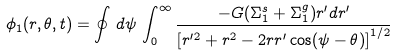Convert formula to latex. <formula><loc_0><loc_0><loc_500><loc_500>\phi _ { 1 } ( r , \theta , t ) = \oint \, d \psi \, \int _ { 0 } ^ { \infty } \frac { - G ( \Sigma _ { 1 } ^ { s } + \Sigma _ { 1 } ^ { g } ) r ^ { \prime } d r ^ { \prime } } { \left [ r ^ { \prime 2 } + r ^ { 2 } - 2 r r ^ { \prime } \cos ( \psi - \theta ) \right ] ^ { 1 / 2 } } \</formula> 